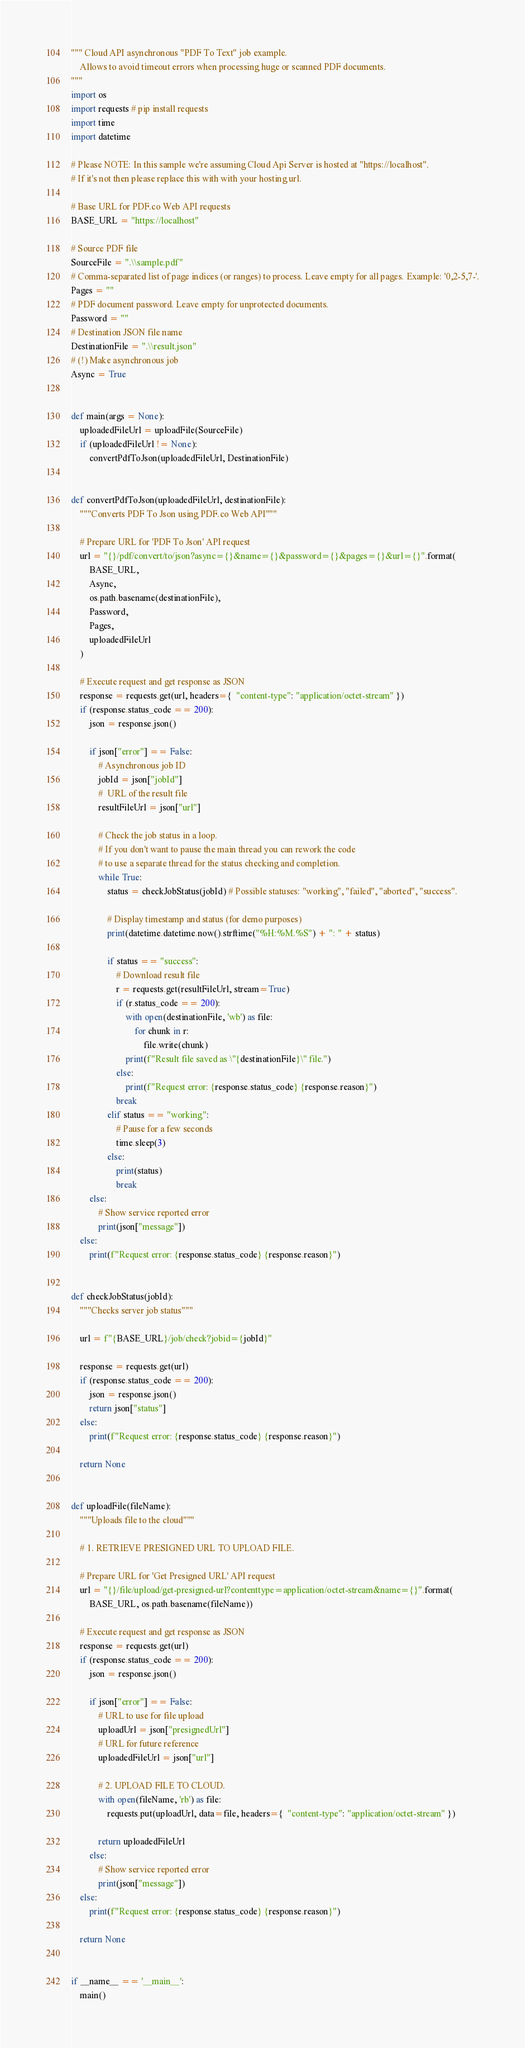Convert code to text. <code><loc_0><loc_0><loc_500><loc_500><_Python_>""" Cloud API asynchronous "PDF To Text" job example.
    Allows to avoid timeout errors when processing huge or scanned PDF documents.
"""
import os
import requests # pip install requests
import time
import datetime

# Please NOTE: In this sample we're assuming Cloud Api Server is hosted at "https://localhost". 
# If it's not then please replace this with with your hosting url.

# Base URL for PDF.co Web API requests
BASE_URL = "https://localhost"

# Source PDF file
SourceFile = ".\\sample.pdf"
# Comma-separated list of page indices (or ranges) to process. Leave empty for all pages. Example: '0,2-5,7-'.
Pages = ""
# PDF document password. Leave empty for unprotected documents.
Password = ""
# Destination JSON file name
DestinationFile = ".\\result.json"
# (!) Make asynchronous job
Async = True


def main(args = None):
    uploadedFileUrl = uploadFile(SourceFile)
    if (uploadedFileUrl != None):
        convertPdfToJson(uploadedFileUrl, DestinationFile)


def convertPdfToJson(uploadedFileUrl, destinationFile):
    """Converts PDF To Json using PDF.co Web API"""

    # Prepare URL for 'PDF To Json' API request
    url = "{}/pdf/convert/to/json?async={}&name={}&password={}&pages={}&url={}".format(
        BASE_URL,
        Async,
        os.path.basename(destinationFile),
        Password,
        Pages,
        uploadedFileUrl
    )

    # Execute request and get response as JSON
    response = requests.get(url, headers={  "content-type": "application/octet-stream" })
    if (response.status_code == 200):
        json = response.json()

        if json["error"] == False:
            # Asynchronous job ID
            jobId = json["jobId"]
            #  URL of the result file
            resultFileUrl = json["url"]
            
            # Check the job status in a loop. 
            # If you don't want to pause the main thread you can rework the code 
            # to use a separate thread for the status checking and completion.
            while True:
                status = checkJobStatus(jobId) # Possible statuses: "working", "failed", "aborted", "success".
                
                # Display timestamp and status (for demo purposes)
                print(datetime.datetime.now().strftime("%H:%M.%S") + ": " + status)
                
                if status == "success":
                    # Download result file
                    r = requests.get(resultFileUrl, stream=True)
                    if (r.status_code == 200):
                        with open(destinationFile, 'wb') as file:
                            for chunk in r:
                                file.write(chunk)
                        print(f"Result file saved as \"{destinationFile}\" file.")
                    else:
                        print(f"Request error: {response.status_code} {response.reason}")
                    break
                elif status == "working":
                    # Pause for a few seconds
                    time.sleep(3)
                else:
                    print(status)
                    break
        else:
            # Show service reported error
            print(json["message"])
    else:
        print(f"Request error: {response.status_code} {response.reason}")


def checkJobStatus(jobId):
    """Checks server job status"""

    url = f"{BASE_URL}/job/check?jobid={jobId}"
    
    response = requests.get(url)
    if (response.status_code == 200):
        json = response.json()
        return json["status"]
    else:
        print(f"Request error: {response.status_code} {response.reason}")

    return None


def uploadFile(fileName):
    """Uploads file to the cloud"""
    
    # 1. RETRIEVE PRESIGNED URL TO UPLOAD FILE.

    # Prepare URL for 'Get Presigned URL' API request
    url = "{}/file/upload/get-presigned-url?contenttype=application/octet-stream&name={}".format(
        BASE_URL, os.path.basename(fileName))
    
    # Execute request and get response as JSON
    response = requests.get(url)
    if (response.status_code == 200):
        json = response.json()
        
        if json["error"] == False:
            # URL to use for file upload
            uploadUrl = json["presignedUrl"]
            # URL for future reference
            uploadedFileUrl = json["url"]

            # 2. UPLOAD FILE TO CLOUD.
            with open(fileName, 'rb') as file:
                requests.put(uploadUrl, data=file, headers={  "content-type": "application/octet-stream" })

            return uploadedFileUrl
        else:
            # Show service reported error
            print(json["message"])    
    else:
        print(f"Request error: {response.status_code} {response.reason}")

    return None


if __name__ == '__main__':
    main()</code> 